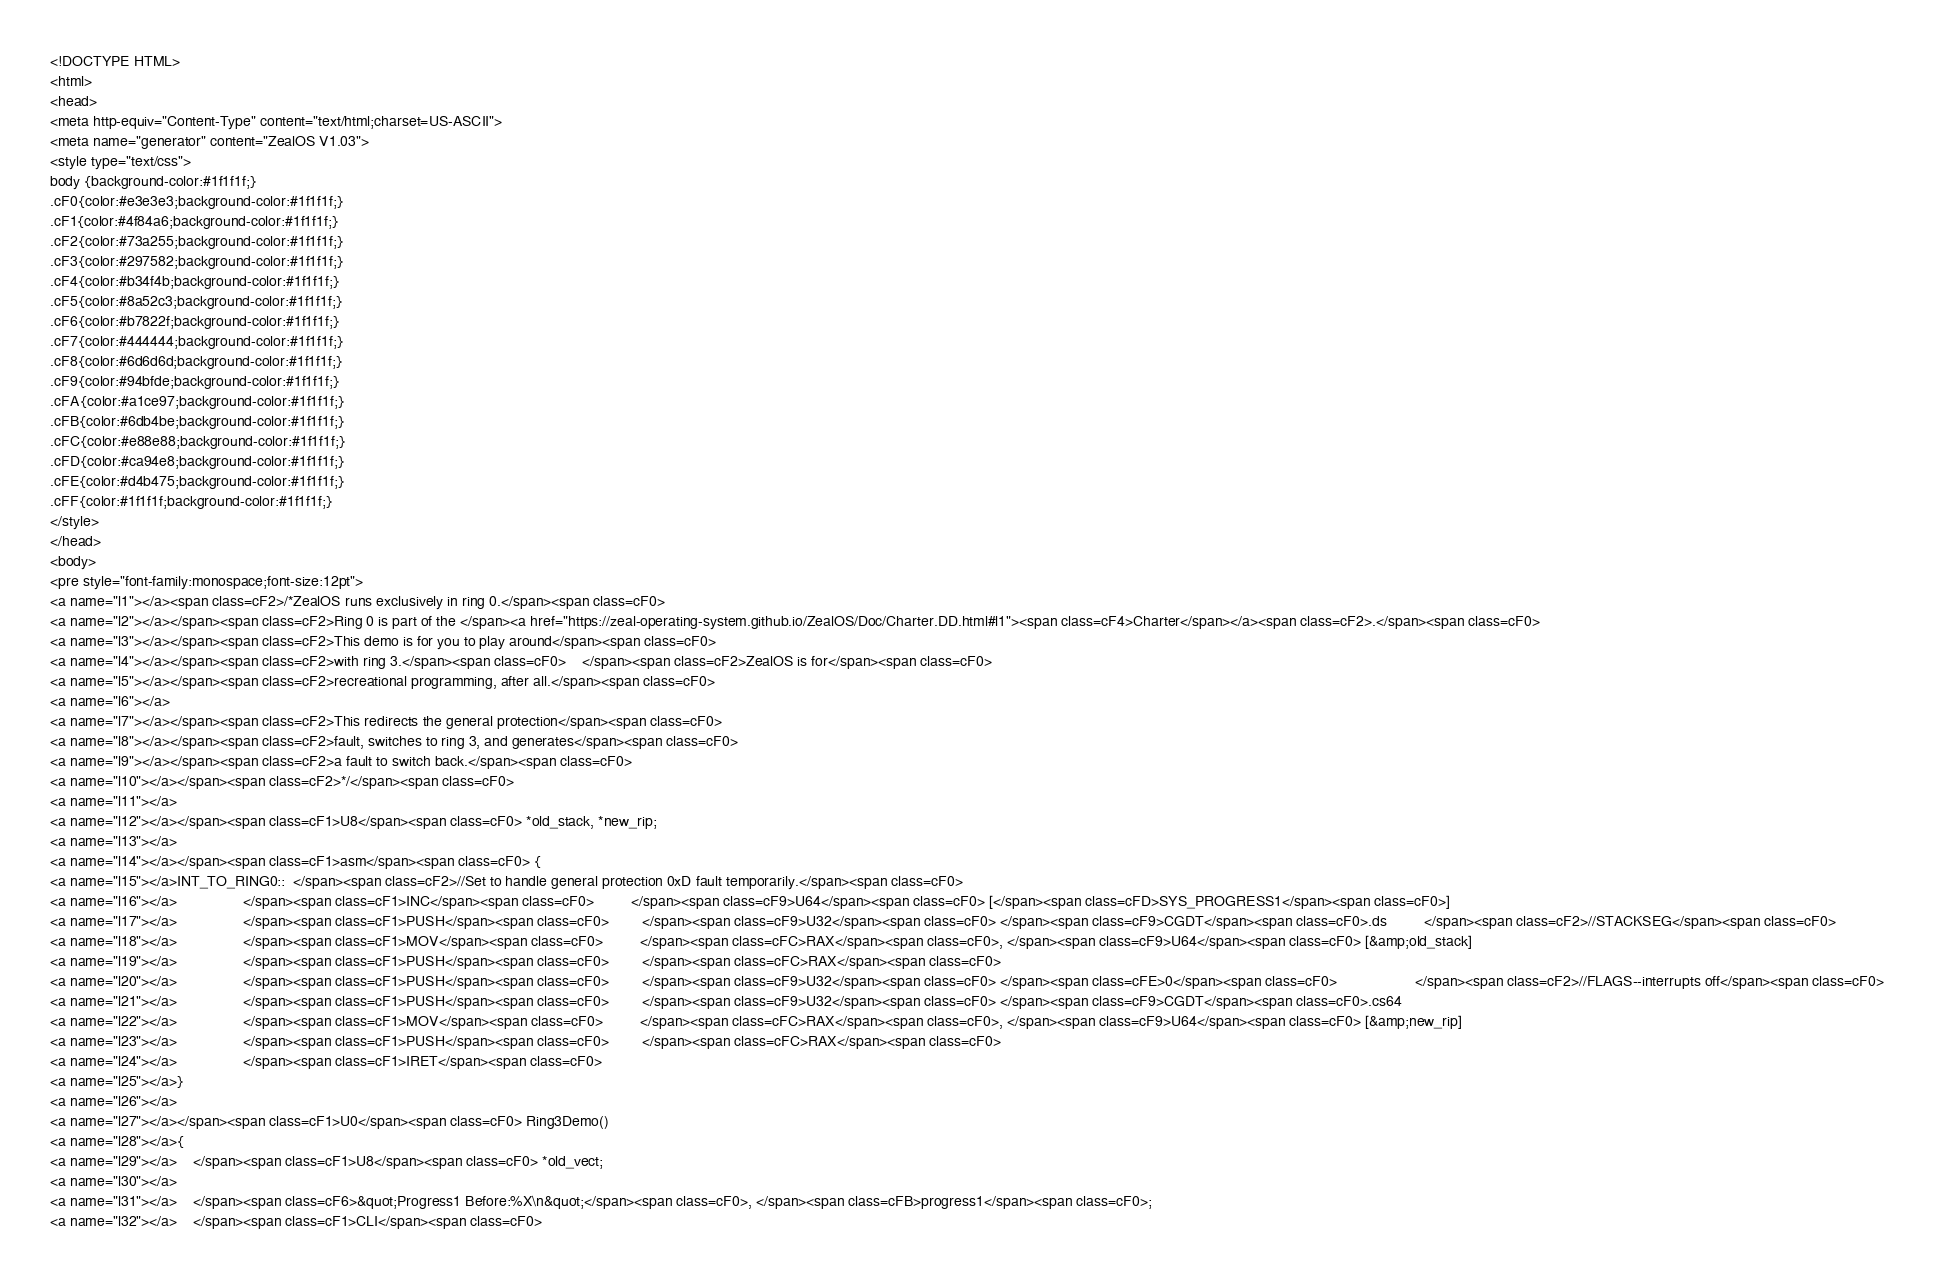Convert code to text. <code><loc_0><loc_0><loc_500><loc_500><_HTML_><!DOCTYPE HTML>
<html>
<head>
<meta http-equiv="Content-Type" content="text/html;charset=US-ASCII">
<meta name="generator" content="ZealOS V1.03">
<style type="text/css">
body {background-color:#1f1f1f;}
.cF0{color:#e3e3e3;background-color:#1f1f1f;}
.cF1{color:#4f84a6;background-color:#1f1f1f;}
.cF2{color:#73a255;background-color:#1f1f1f;}
.cF3{color:#297582;background-color:#1f1f1f;}
.cF4{color:#b34f4b;background-color:#1f1f1f;}
.cF5{color:#8a52c3;background-color:#1f1f1f;}
.cF6{color:#b7822f;background-color:#1f1f1f;}
.cF7{color:#444444;background-color:#1f1f1f;}
.cF8{color:#6d6d6d;background-color:#1f1f1f;}
.cF9{color:#94bfde;background-color:#1f1f1f;}
.cFA{color:#a1ce97;background-color:#1f1f1f;}
.cFB{color:#6db4be;background-color:#1f1f1f;}
.cFC{color:#e88e88;background-color:#1f1f1f;}
.cFD{color:#ca94e8;background-color:#1f1f1f;}
.cFE{color:#d4b475;background-color:#1f1f1f;}
.cFF{color:#1f1f1f;background-color:#1f1f1f;}
</style>
</head>
<body>
<pre style="font-family:monospace;font-size:12pt">
<a name="l1"></a><span class=cF2>/*ZealOS runs exclusively in ring 0.</span><span class=cF0>
<a name="l2"></a></span><span class=cF2>Ring 0 is part of the </span><a href="https://zeal-operating-system.github.io/ZealOS/Doc/Charter.DD.html#l1"><span class=cF4>Charter</span></a><span class=cF2>.</span><span class=cF0>
<a name="l3"></a></span><span class=cF2>This demo is for you to play around</span><span class=cF0>
<a name="l4"></a></span><span class=cF2>with ring 3.</span><span class=cF0>    </span><span class=cF2>ZealOS is for</span><span class=cF0>
<a name="l5"></a></span><span class=cF2>recreational programming, after all.</span><span class=cF0>
<a name="l6"></a>
<a name="l7"></a></span><span class=cF2>This redirects the general protection</span><span class=cF0>
<a name="l8"></a></span><span class=cF2>fault, switches to ring 3, and generates</span><span class=cF0>
<a name="l9"></a></span><span class=cF2>a fault to switch back.</span><span class=cF0>
<a name="l10"></a></span><span class=cF2>*/</span><span class=cF0>
<a name="l11"></a>
<a name="l12"></a></span><span class=cF1>U8</span><span class=cF0> *old_stack, *new_rip;
<a name="l13"></a>
<a name="l14"></a></span><span class=cF1>asm</span><span class=cF0> {
<a name="l15"></a>INT_TO_RING0::  </span><span class=cF2>//Set to handle general protection 0xD fault temporarily.</span><span class=cF0>
<a name="l16"></a>                </span><span class=cF1>INC</span><span class=cF0>         </span><span class=cF9>U64</span><span class=cF0> [</span><span class=cFD>SYS_PROGRESS1</span><span class=cF0>]
<a name="l17"></a>                </span><span class=cF1>PUSH</span><span class=cF0>        </span><span class=cF9>U32</span><span class=cF0> </span><span class=cF9>CGDT</span><span class=cF0>.ds         </span><span class=cF2>//STACKSEG</span><span class=cF0>
<a name="l18"></a>                </span><span class=cF1>MOV</span><span class=cF0>         </span><span class=cFC>RAX</span><span class=cF0>, </span><span class=cF9>U64</span><span class=cF0> [&amp;old_stack]
<a name="l19"></a>                </span><span class=cF1>PUSH</span><span class=cF0>        </span><span class=cFC>RAX</span><span class=cF0>
<a name="l20"></a>                </span><span class=cF1>PUSH</span><span class=cF0>        </span><span class=cF9>U32</span><span class=cF0> </span><span class=cFE>0</span><span class=cF0>                   </span><span class=cF2>//FLAGS--interrupts off</span><span class=cF0>
<a name="l21"></a>                </span><span class=cF1>PUSH</span><span class=cF0>        </span><span class=cF9>U32</span><span class=cF0> </span><span class=cF9>CGDT</span><span class=cF0>.cs64
<a name="l22"></a>                </span><span class=cF1>MOV</span><span class=cF0>         </span><span class=cFC>RAX</span><span class=cF0>, </span><span class=cF9>U64</span><span class=cF0> [&amp;new_rip]
<a name="l23"></a>                </span><span class=cF1>PUSH</span><span class=cF0>        </span><span class=cFC>RAX</span><span class=cF0>
<a name="l24"></a>                </span><span class=cF1>IRET</span><span class=cF0>
<a name="l25"></a>}
<a name="l26"></a>
<a name="l27"></a></span><span class=cF1>U0</span><span class=cF0> Ring3Demo()
<a name="l28"></a>{
<a name="l29"></a>    </span><span class=cF1>U8</span><span class=cF0> *old_vect;
<a name="l30"></a>
<a name="l31"></a>    </span><span class=cF6>&quot;Progress1 Before:%X\n&quot;</span><span class=cF0>, </span><span class=cFB>progress1</span><span class=cF0>;
<a name="l32"></a>    </span><span class=cF1>CLI</span><span class=cF0></code> 